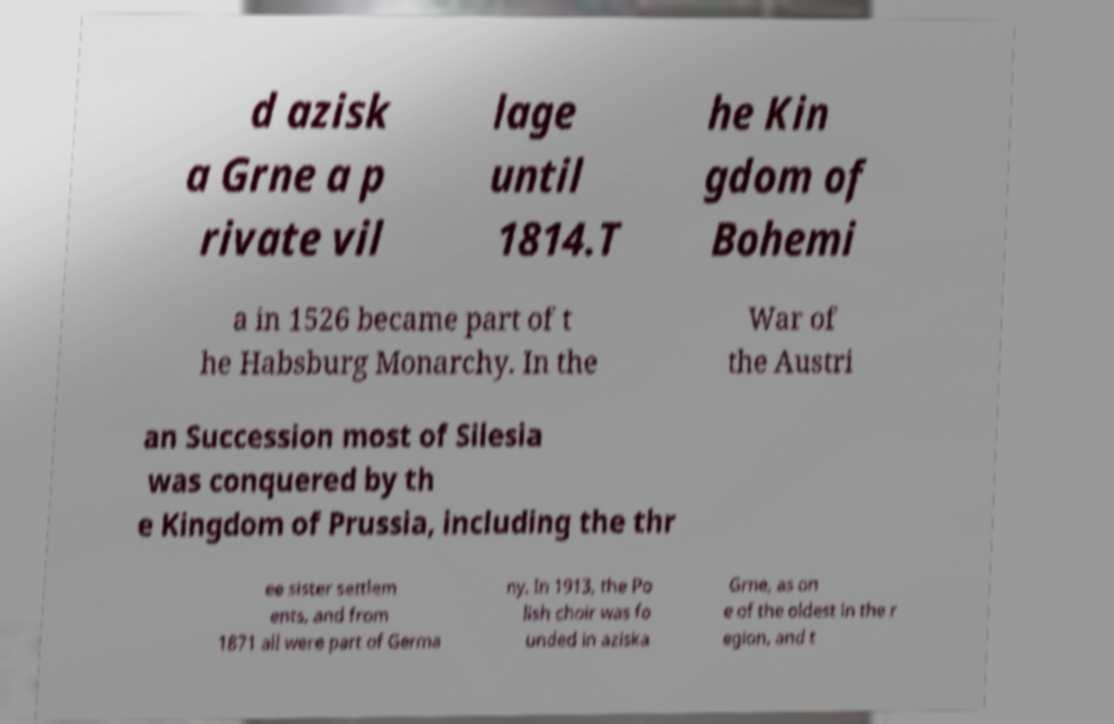Can you read and provide the text displayed in the image?This photo seems to have some interesting text. Can you extract and type it out for me? d azisk a Grne a p rivate vil lage until 1814.T he Kin gdom of Bohemi a in 1526 became part of t he Habsburg Monarchy. In the War of the Austri an Succession most of Silesia was conquered by th e Kingdom of Prussia, including the thr ee sister settlem ents, and from 1871 all were part of Germa ny. In 1913, the Po lish choir was fo unded in aziska Grne, as on e of the oldest in the r egion, and t 